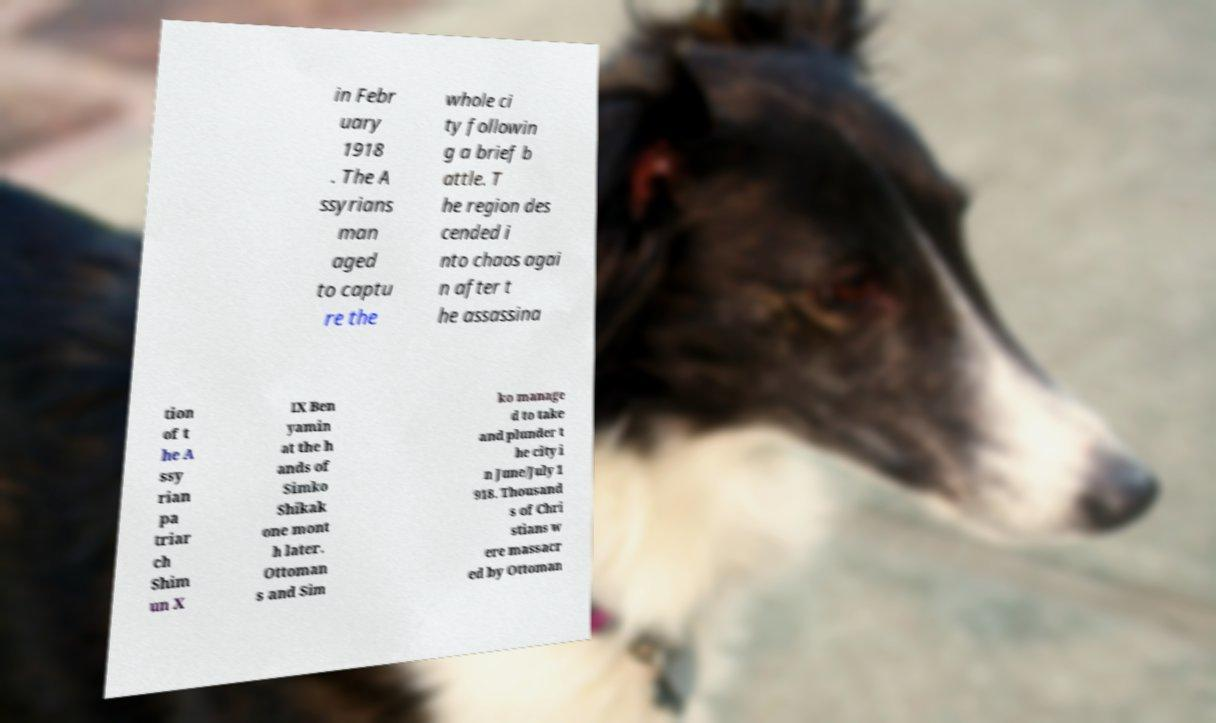Could you assist in decoding the text presented in this image and type it out clearly? in Febr uary 1918 . The A ssyrians man aged to captu re the whole ci ty followin g a brief b attle. T he region des cended i nto chaos agai n after t he assassina tion of t he A ssy rian pa triar ch Shim un X IX Ben yamin at the h ands of Simko Shikak one mont h later. Ottoman s and Sim ko manage d to take and plunder t he city i n June/July 1 918. Thousand s of Chri stians w ere massacr ed by Ottoman 